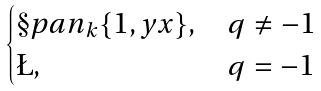<formula> <loc_0><loc_0><loc_500><loc_500>\begin{cases} \S p a n _ { k } \{ 1 , y x \} , & q \neq - 1 \\ \L , & q = - 1 \end{cases}</formula> 